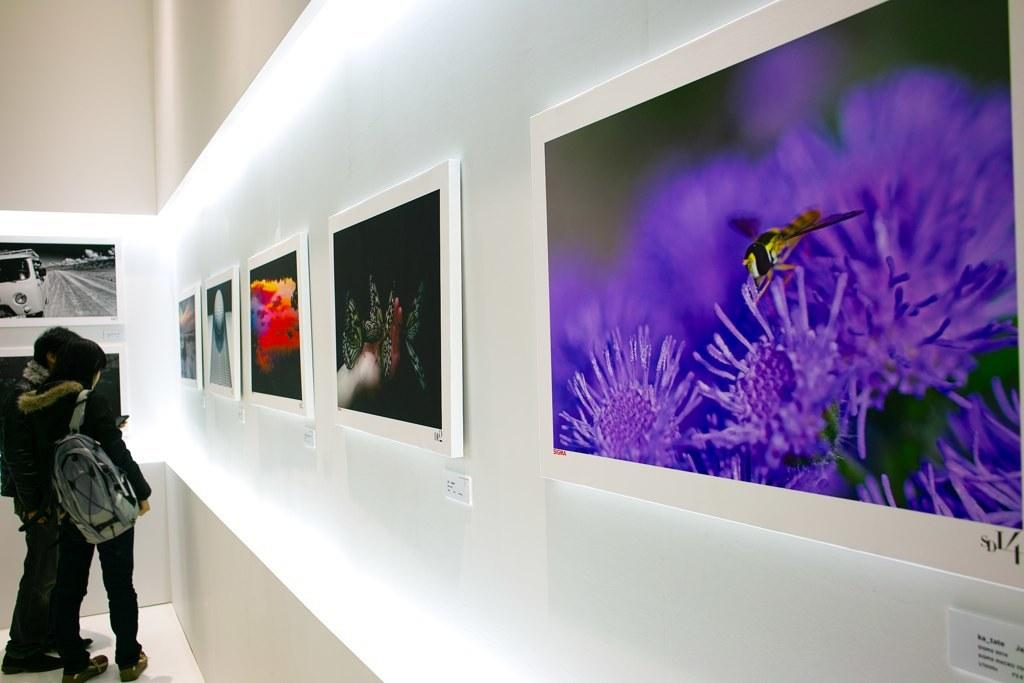How many people are present in the image? There are two people in the image. What are the people doing in the image? The people are looking at pictures in the image. Where are the pictures located? The pictures are in an art gallery. What type of goose can be seen sorting spoons in the image? There is no goose or spoons present in the image; it features two people looking at pictures in an art gallery. 